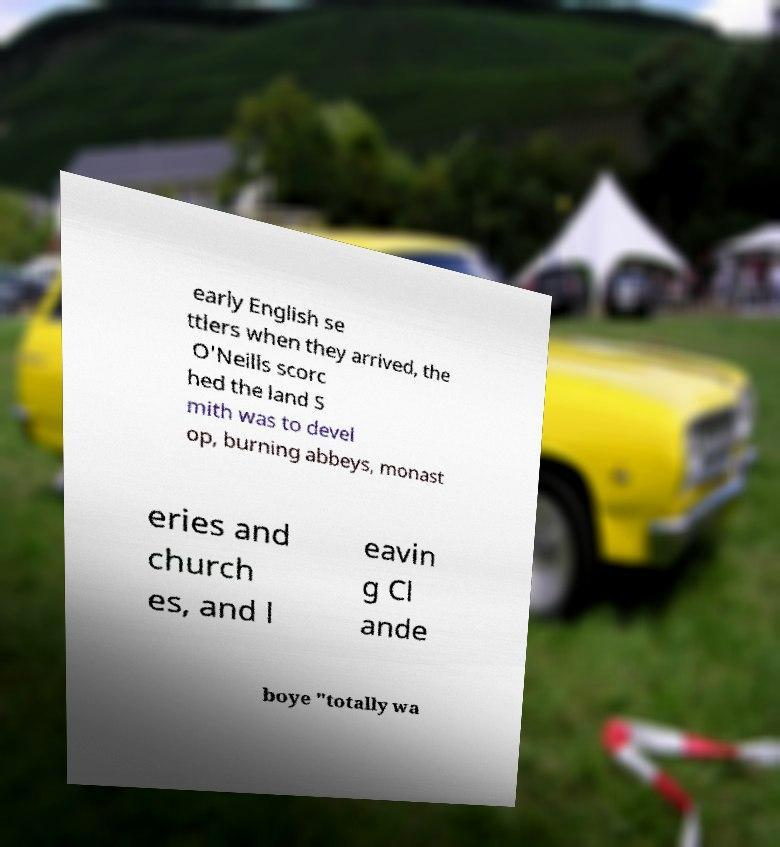What messages or text are displayed in this image? I need them in a readable, typed format. early English se ttlers when they arrived, the O'Neills scorc hed the land S mith was to devel op, burning abbeys, monast eries and church es, and l eavin g Cl ande boye "totally wa 